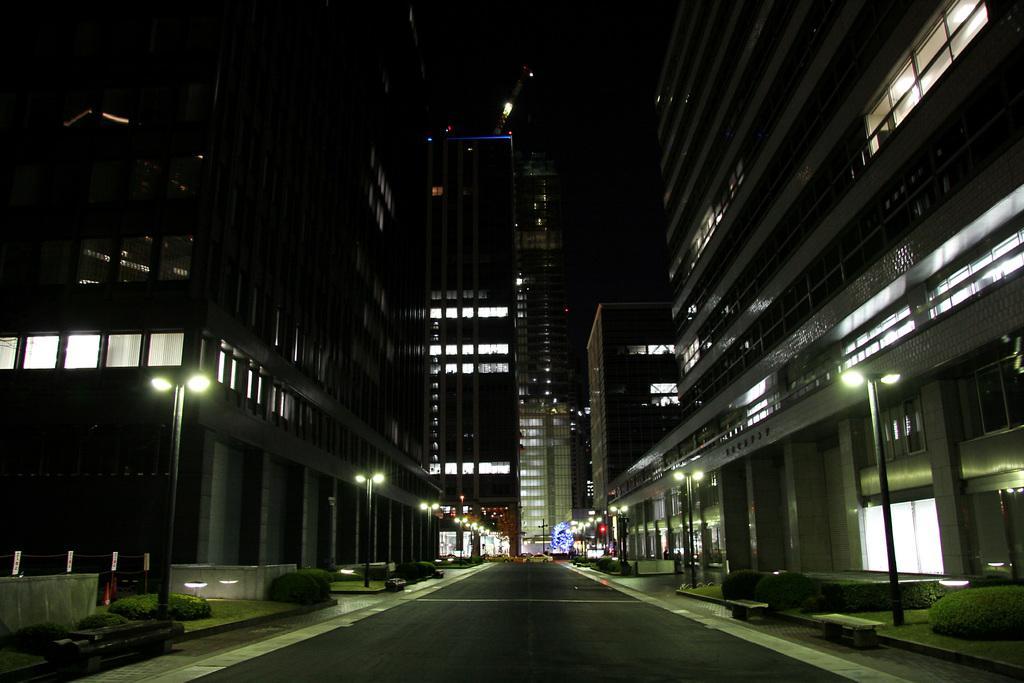In one or two sentences, can you explain what this image depicts? In this image we can see some buildings with windows. We can also see some street poles, pathway, lights, plants and the sky. 